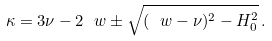Convert formula to latex. <formula><loc_0><loc_0><loc_500><loc_500>\kappa = 3 \nu - 2 \ w \pm \sqrt { ( \ w - \nu ) ^ { 2 } - H _ { 0 } ^ { 2 } } \, .</formula> 